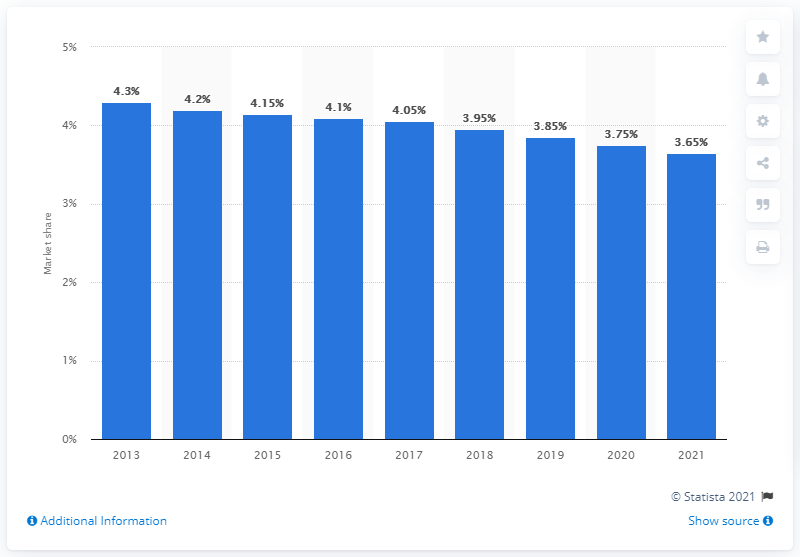Mention a couple of crucial points in this snapshot. In 2015, Johnson & Johnson held 4.15% of the global market share in skin care products. 